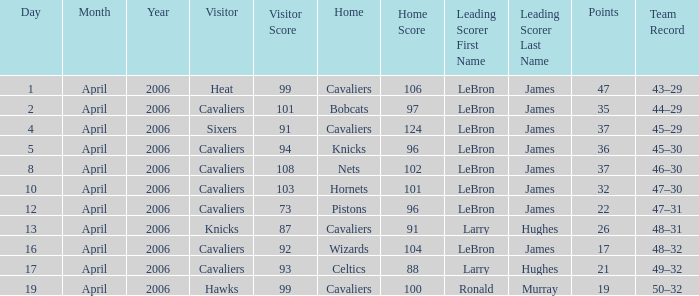What day was the game that had the Cavaliers as visiting team and the Knicks as the home team? 5 April 2006. 